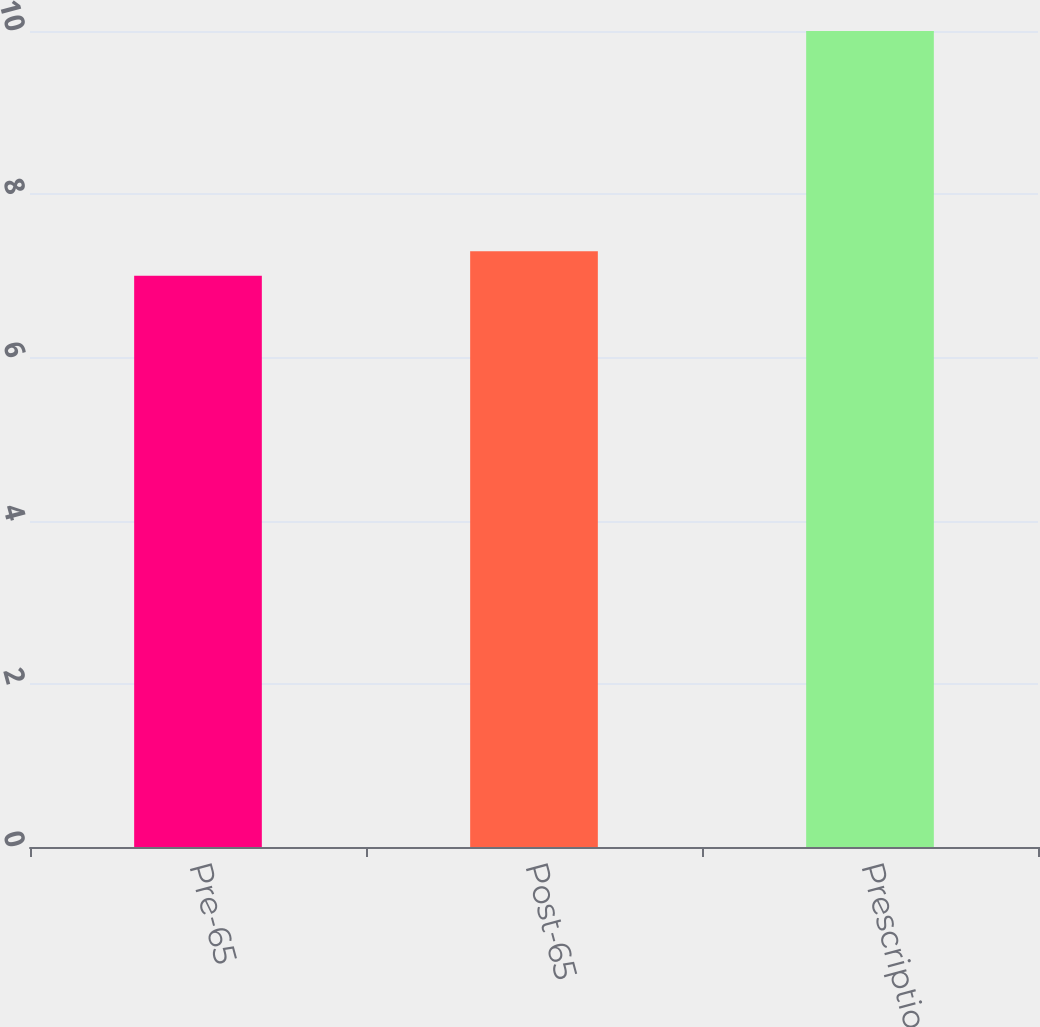Convert chart. <chart><loc_0><loc_0><loc_500><loc_500><bar_chart><fcel>Pre-65<fcel>Post-65<fcel>Prescription drugs<nl><fcel>7<fcel>7.3<fcel>10<nl></chart> 